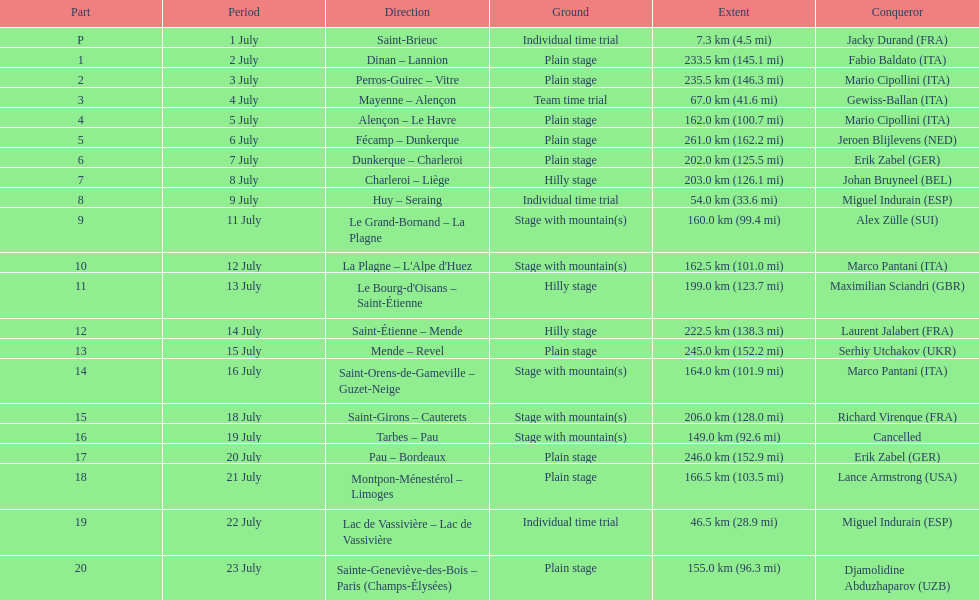How many stages were at least 200 km in length in the 1995 tour de france? 9. 